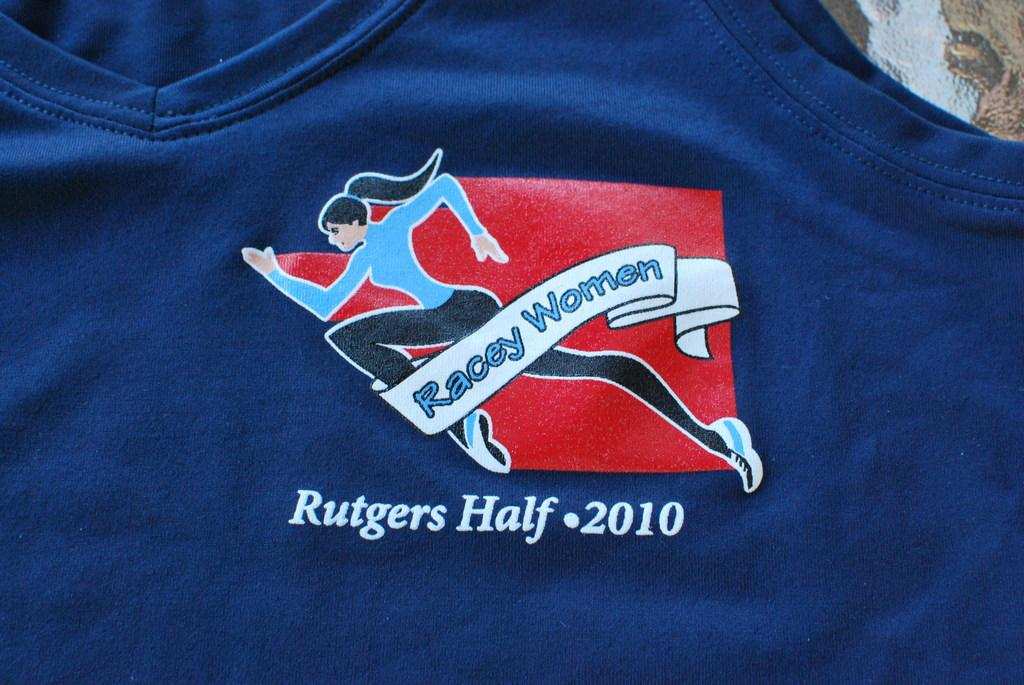Provide a one-sentence caption for the provided image. A teeshirt patch for women racing in the 2010 Rutgers half has a red background. 